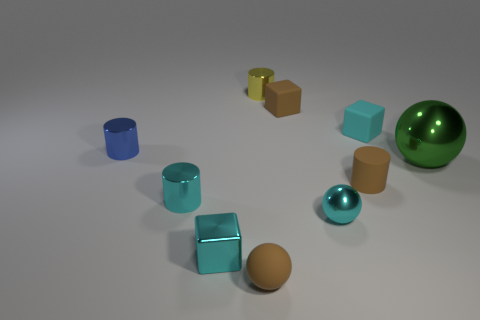Subtract 1 cylinders. How many cylinders are left? 3 Subtract all cylinders. How many objects are left? 6 Subtract all brown rubber objects. Subtract all small gray rubber cubes. How many objects are left? 7 Add 9 tiny blue shiny things. How many tiny blue shiny things are left? 10 Add 8 rubber cylinders. How many rubber cylinders exist? 9 Subtract 1 brown blocks. How many objects are left? 9 